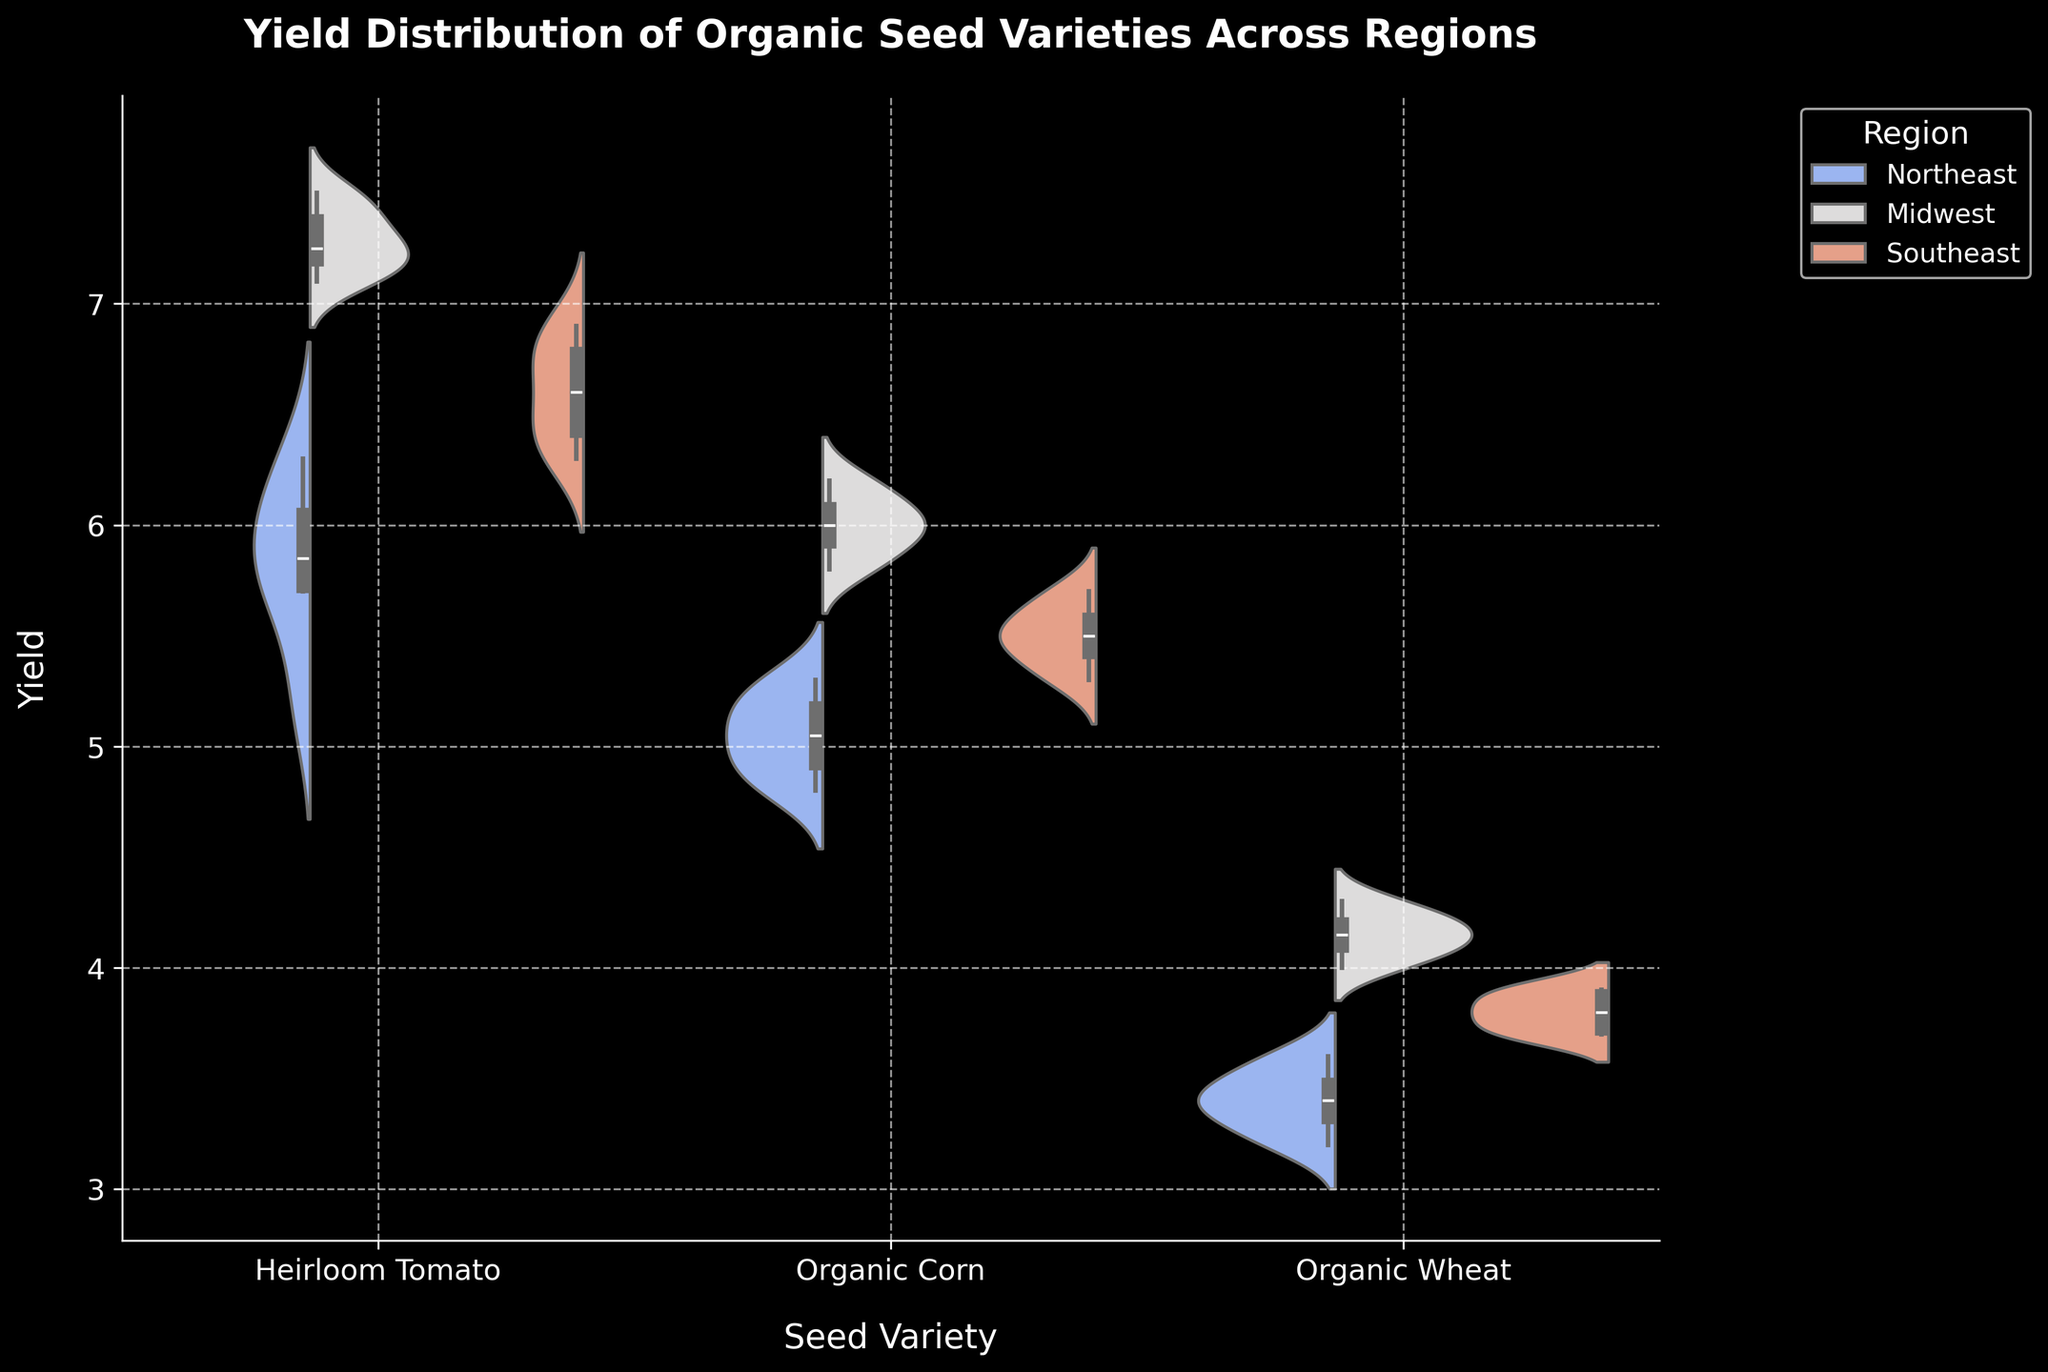What's the title of the figure? The title of the figure is displayed at the top of the chart. It is "Yield Distribution of Organic Seed Varieties Across Regions".
Answer: Yield Distribution of Organic Seed Varieties Across Regions What do the different colors in the plot represent? The different colors in the plot represent different regions. There are typically legends or the color coding itself that shows which color matches each region (Northeast, Midwest, Southeast).
Answer: Different regions How many seed varieties are compared in the figure? The seed varieties are displayed on the x-axis. By counting them, we can see there are three seed varieties: Heirloom Tomato, Organic Corn, and Organic Wheat.
Answer: Three Which region has the highest median yield for Heirloom Tomato? Look at the box plot component inside the violin plot for Heirloom Tomato and find the region with the highest median line (the middle line of the box). For Heirloom Tomato, the Midwest region shows the highest median yield.
Answer: Midwest Compare the interquartile range (IQR) of Organic Corn yield in the Midwest and Southeast. The IQR is the range between the first and third quartile (the length of the box in the plot). For Organic Corn, compare the lengths of the boxes in the Midwest and Southeast regions. The IQR is larger in the Midwest compared to the Southeast.
Answer: Larger in Midwest Which seed variety shows the biggest difference in yield distribution between regions? Observe the width and spread of the violin plots for each seed variety across the different regions. The seed variety with the most noticeable variation in distribution width and spread is Heirloom Tomato, as there is a clear difference in distribution between the regions.
Answer: Heirloom Tomato What is the typical yield range for Organic Wheat in the Northeast? Look at the violin plot and the box plot for Organic Wheat in the Northeast. The typical yield range (interquartile range, IQR) is from the first quartile to the third quartile. For the Northeast, this range is approximately between 3.3 and 3.6.
Answer: 3.3 to 3.6 Is there any seed variety where the average yield in the Southeast is higher than any other region? Averaging can be approximated by looking at the overall shape of the violin plots and the central tendency indicated by the box plots. For Organic Wheat, the Southeast shows a higher average yield compared to the Northeast.
Answer: Organic Wheat in Southeast compared to Northeast Which seed variety has the most consistent yield across all regions? Consistency can be interpreted as having less variation or spread in the violin plots across different regions. Organic Wheat shows the most consistent yield across all regions with relatively narrow and similar violin plots.
Answer: Organic Wheat How do the yield distributions of Organic Corn in the Northeast and Southeast compare? Examine the shape and spread of the violin plots and the position of the box plots for Organic Corn in the Northeast and Southeast. The Northeast shows a slightly lower and tighter distribution compared to the Southeast, which has a slightly higher and broader distribution.
Answer: Northeast is lower and tighter, Southeast is higher and broader 